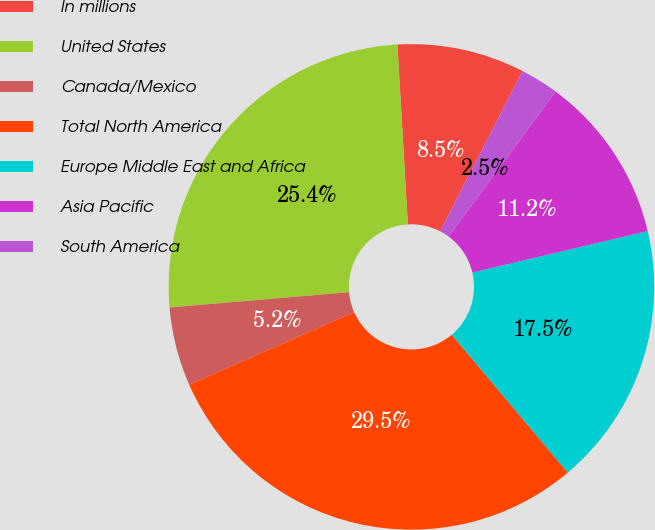<chart> <loc_0><loc_0><loc_500><loc_500><pie_chart><fcel>In millions<fcel>United States<fcel>Canada/Mexico<fcel>Total North America<fcel>Europe Middle East and Africa<fcel>Asia Pacific<fcel>South America<nl><fcel>8.49%<fcel>25.43%<fcel>5.25%<fcel>29.54%<fcel>17.55%<fcel>11.19%<fcel>2.55%<nl></chart> 